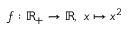Convert formula to latex. <formula><loc_0><loc_0><loc_500><loc_500>f \colon \mathbb { R } _ { + } \to \mathbb { R } , \ x \mapsto x ^ { 2 }</formula> 